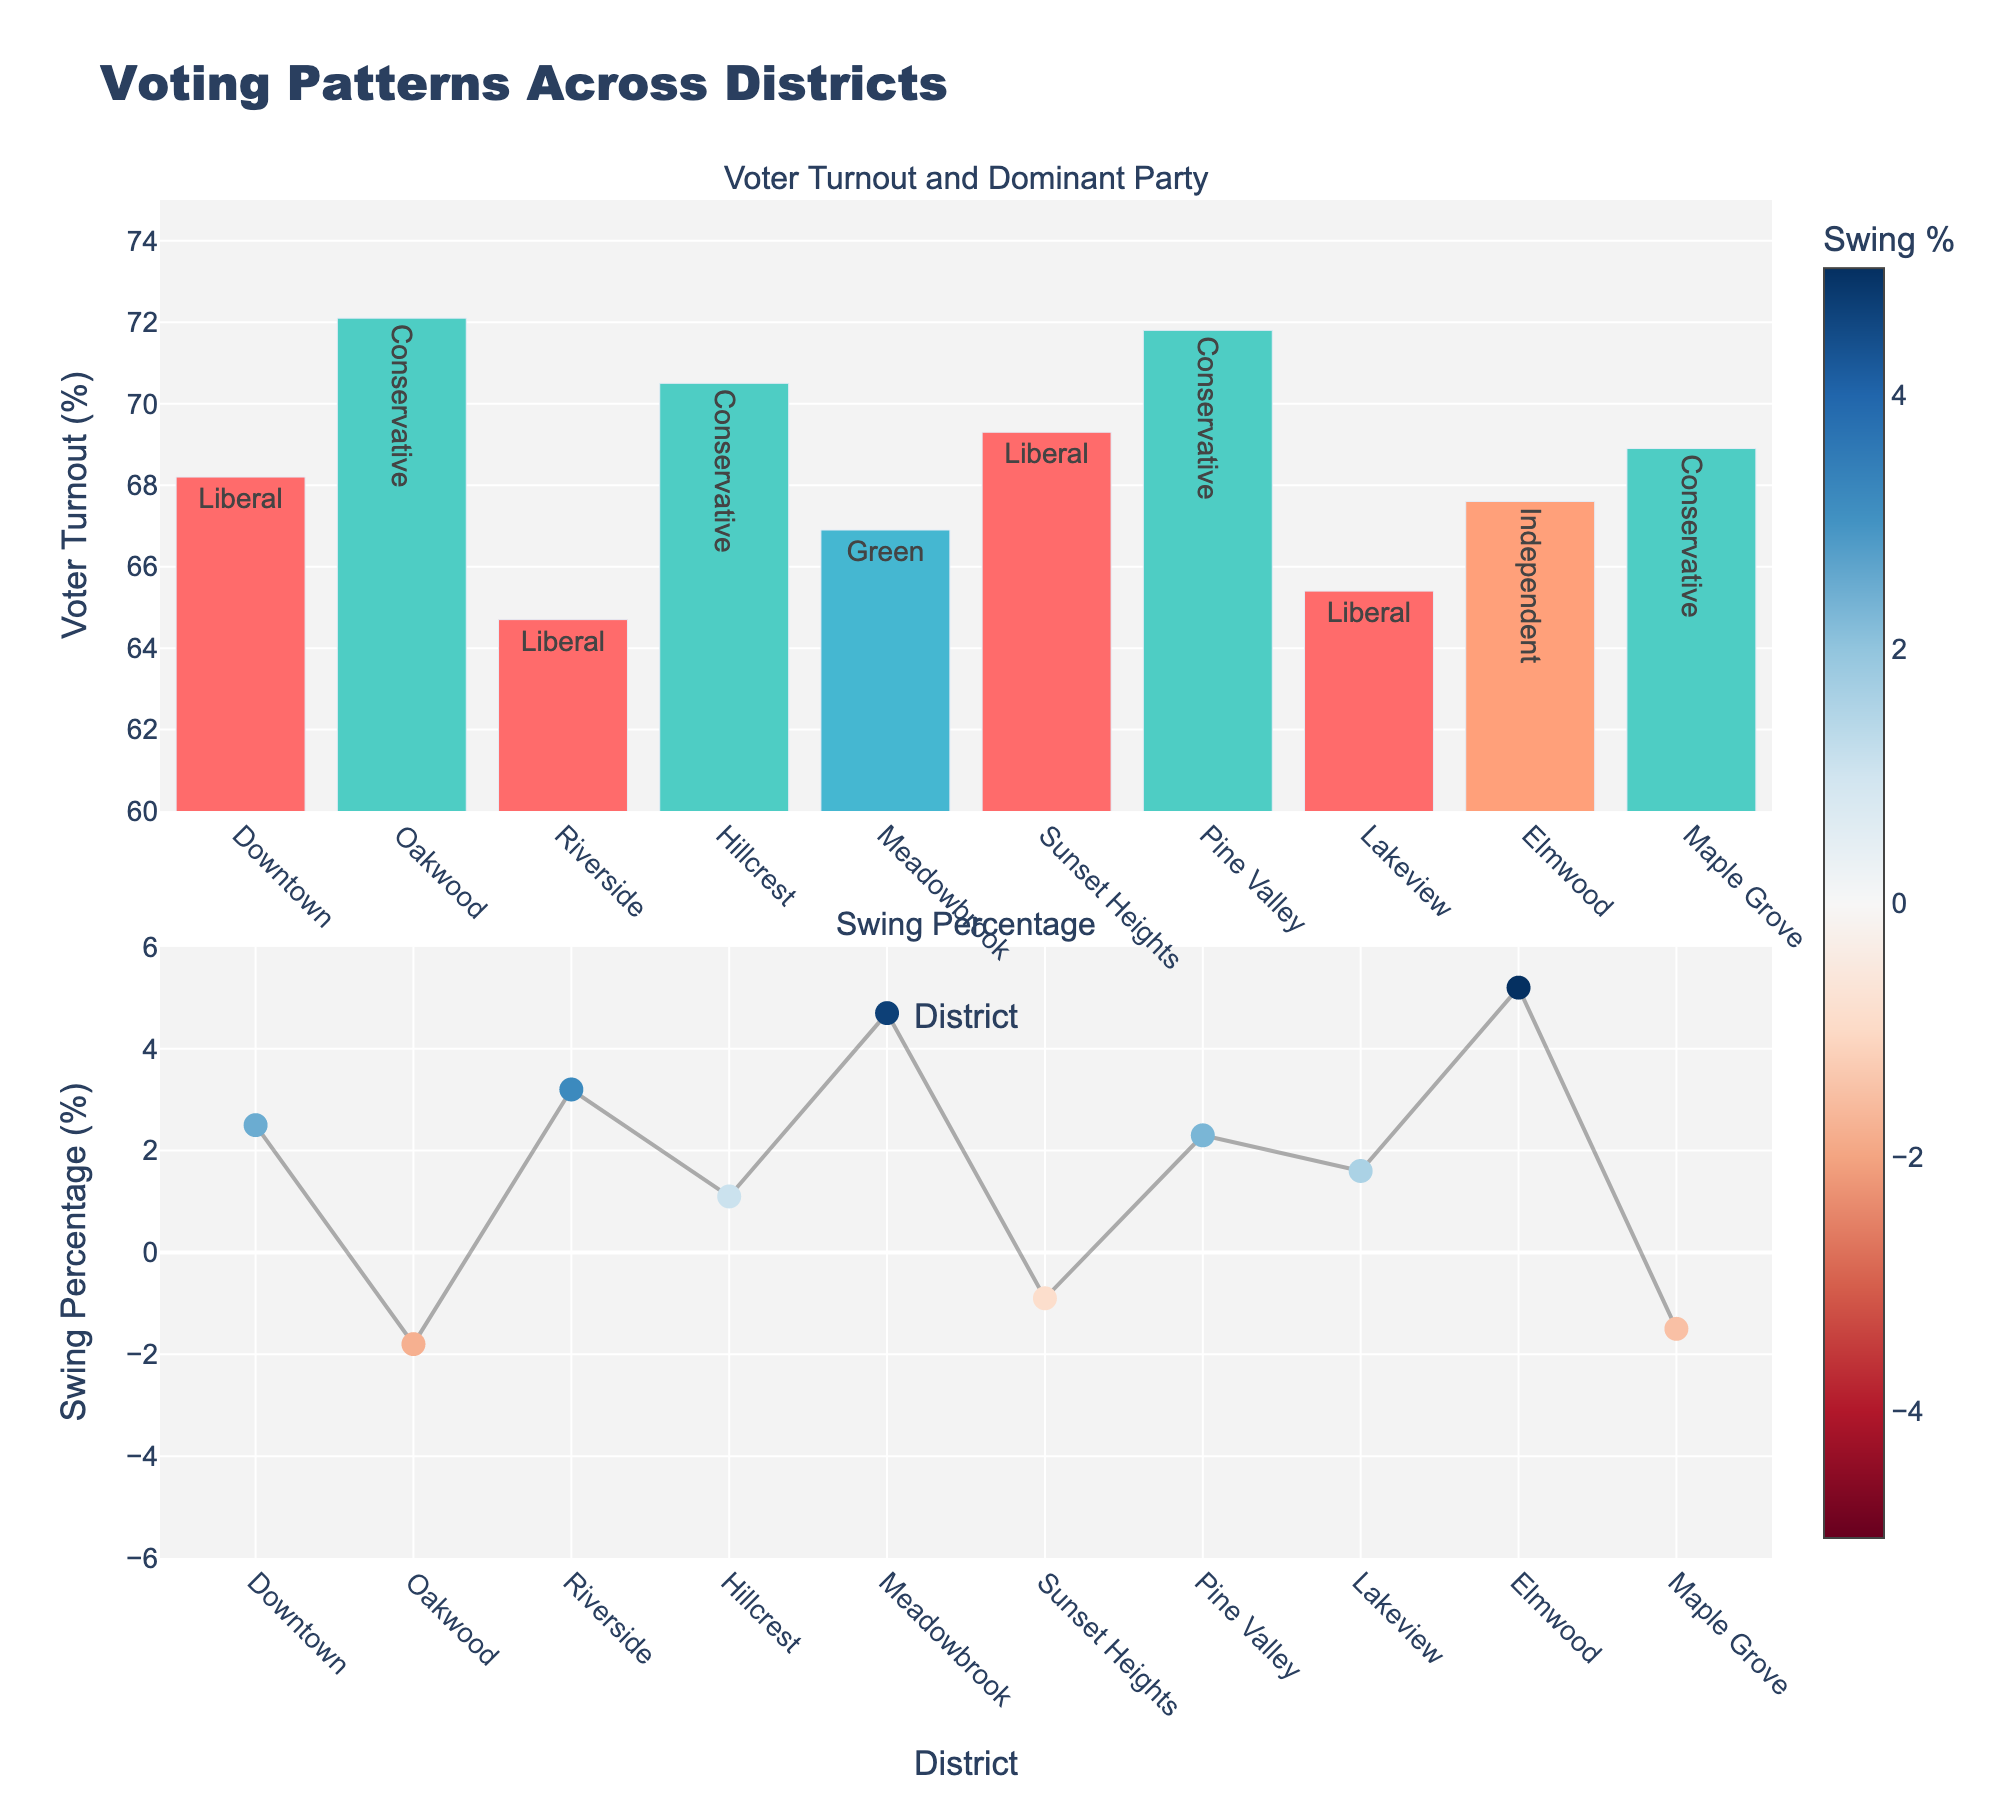what is the dominant party in Downtown? The first subplot shows voter turnout and dominant party for each district. From the hover information, we can see the dominant party for Downtown
Answer: Liberal Which district had the highest voter turnout? The first subplot shows the voter turnout bars. By comparing the heights and hover information, Oakwood has the highest value
Answer: Oakwood How much did the swing percentage change in Hillcrest? The second subplot shows swing percentage as a line with markers. By examining the hover information at Hillcrest, it shows 1.1%
Answer: 1.1% Which district exhibited the lowest voter turnout? By comparing the voter turnout bars in the first subplot, Riverside has the lowest height
Answer: Riverside Which district has the largest positive swing percentage? The color bar in the second subplot indicates swing percentage. The highest positive value can be found in Elmwood, with 5.2%
Answer: Elmwood Compare the voter turnout between Pine Valley and Lakeview? Pine Valley and Lakeview are shown in the first subplot. Pine Valley has 71.8% while Lakeview has 65.4%
Answer: Pine Valley has higher turnout What is the average voter turnout across all districts? Sum all voter turnout percentages and divide by the number of districts (68.2 + 72.1 + 64.7 + 70.5 + 66.9 + 69.3 + 71.8 + 65.4 + 67.6 + 68.9) / 10
Answer: 68.54% What is the range of swing percentages across the districts? The second subplot provides swing percentages from different markers. The range is found by subtracting the minimum (-1.8% in Oakwood) from the maximum (5.2% in Elmwood)
Answer: 7% How does the swing percentage in Sunset Heights compare to Meadowbrook? Compare markers in the second subplot. Sunset Heights has a swing of -0.9%, while Meadowbrook has a swing of 4.7%
Answer: Meadowbrook is higher Which party is dominant in more districts, Liberal or Conservative? Count the number of districts for each party in the first subplot. Liberal is dominant in 4 districts (Downtown, Riverside, Sunset Heights, Lakeview), Conservative in 4 (Oakwood, Hillcrest, Pine Valley, Maple Grove)
Answer: Equal, both have 4 districts 